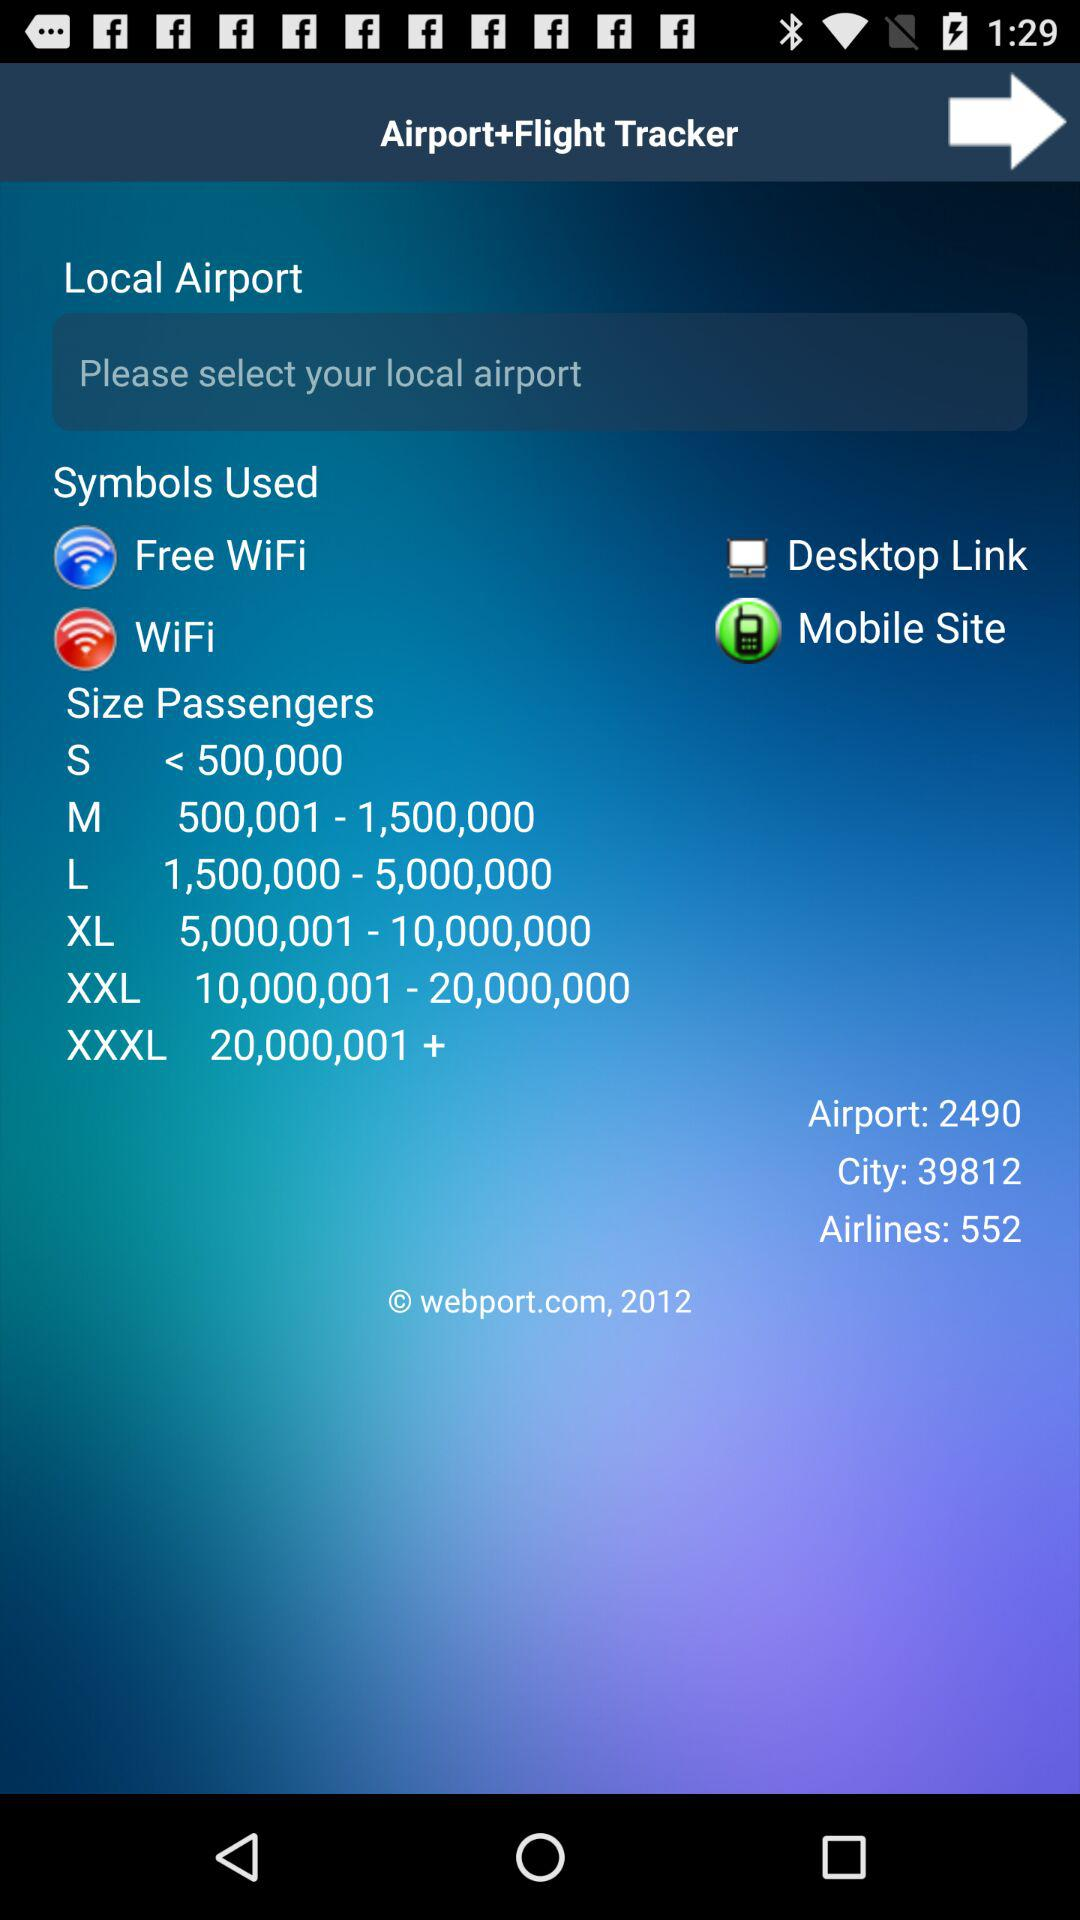What is the total number of airports? The total number of airports is 2490. 